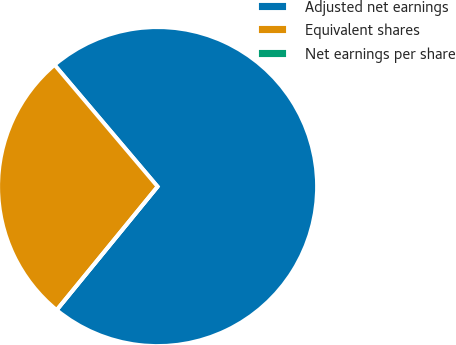Convert chart. <chart><loc_0><loc_0><loc_500><loc_500><pie_chart><fcel>Adjusted net earnings<fcel>Equivalent shares<fcel>Net earnings per share<nl><fcel>72.09%<fcel>27.91%<fcel>0.0%<nl></chart> 